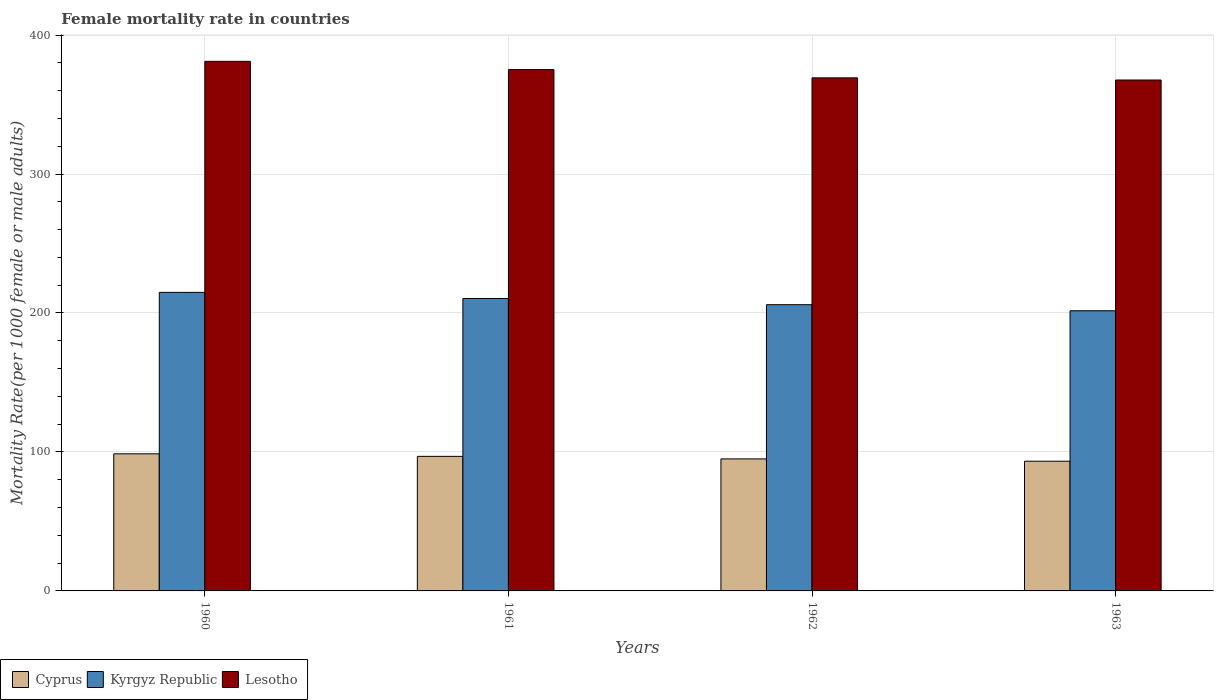How many different coloured bars are there?
Give a very brief answer. 3. Are the number of bars on each tick of the X-axis equal?
Ensure brevity in your answer.  Yes. How many bars are there on the 1st tick from the right?
Offer a very short reply. 3. In how many cases, is the number of bars for a given year not equal to the number of legend labels?
Make the answer very short. 0. What is the female mortality rate in Cyprus in 1960?
Keep it short and to the point. 98.65. Across all years, what is the maximum female mortality rate in Lesotho?
Offer a terse response. 381.07. Across all years, what is the minimum female mortality rate in Kyrgyz Republic?
Offer a terse response. 201.59. What is the total female mortality rate in Lesotho in the graph?
Ensure brevity in your answer.  1493.04. What is the difference between the female mortality rate in Cyprus in 1960 and that in 1962?
Provide a short and direct response. 3.65. What is the difference between the female mortality rate in Cyprus in 1962 and the female mortality rate in Lesotho in 1961?
Your response must be concise. -280.13. What is the average female mortality rate in Kyrgyz Republic per year?
Keep it short and to the point. 208.2. In the year 1961, what is the difference between the female mortality rate in Cyprus and female mortality rate in Kyrgyz Republic?
Your answer should be compact. -113.57. In how many years, is the female mortality rate in Cyprus greater than 80?
Your response must be concise. 4. What is the ratio of the female mortality rate in Cyprus in 1960 to that in 1962?
Ensure brevity in your answer.  1.04. Is the difference between the female mortality rate in Cyprus in 1961 and 1963 greater than the difference between the female mortality rate in Kyrgyz Republic in 1961 and 1963?
Make the answer very short. No. What is the difference between the highest and the second highest female mortality rate in Kyrgyz Republic?
Ensure brevity in your answer.  4.44. What is the difference between the highest and the lowest female mortality rate in Cyprus?
Provide a succinct answer. 5.32. In how many years, is the female mortality rate in Kyrgyz Republic greater than the average female mortality rate in Kyrgyz Republic taken over all years?
Keep it short and to the point. 2. What does the 2nd bar from the left in 1962 represents?
Provide a short and direct response. Kyrgyz Republic. What does the 3rd bar from the right in 1963 represents?
Offer a terse response. Cyprus. Is it the case that in every year, the sum of the female mortality rate in Cyprus and female mortality rate in Kyrgyz Republic is greater than the female mortality rate in Lesotho?
Offer a terse response. No. How many bars are there?
Offer a terse response. 12. How many years are there in the graph?
Provide a short and direct response. 4. What is the difference between two consecutive major ticks on the Y-axis?
Your answer should be very brief. 100. Does the graph contain any zero values?
Provide a short and direct response. No. How many legend labels are there?
Your answer should be compact. 3. What is the title of the graph?
Offer a very short reply. Female mortality rate in countries. Does "Turkey" appear as one of the legend labels in the graph?
Provide a short and direct response. No. What is the label or title of the X-axis?
Offer a very short reply. Years. What is the label or title of the Y-axis?
Your answer should be very brief. Mortality Rate(per 1000 female or male adults). What is the Mortality Rate(per 1000 female or male adults) in Cyprus in 1960?
Your answer should be compact. 98.65. What is the Mortality Rate(per 1000 female or male adults) of Kyrgyz Republic in 1960?
Make the answer very short. 214.84. What is the Mortality Rate(per 1000 female or male adults) of Lesotho in 1960?
Your answer should be very brief. 381.07. What is the Mortality Rate(per 1000 female or male adults) in Cyprus in 1961?
Your answer should be compact. 96.83. What is the Mortality Rate(per 1000 female or male adults) in Kyrgyz Republic in 1961?
Your answer should be very brief. 210.4. What is the Mortality Rate(per 1000 female or male adults) in Lesotho in 1961?
Provide a succinct answer. 375.13. What is the Mortality Rate(per 1000 female or male adults) in Cyprus in 1962?
Your answer should be compact. 95. What is the Mortality Rate(per 1000 female or male adults) in Kyrgyz Republic in 1962?
Provide a succinct answer. 205.97. What is the Mortality Rate(per 1000 female or male adults) in Lesotho in 1962?
Offer a very short reply. 369.19. What is the Mortality Rate(per 1000 female or male adults) in Cyprus in 1963?
Offer a very short reply. 93.34. What is the Mortality Rate(per 1000 female or male adults) of Kyrgyz Republic in 1963?
Make the answer very short. 201.59. What is the Mortality Rate(per 1000 female or male adults) in Lesotho in 1963?
Provide a short and direct response. 367.65. Across all years, what is the maximum Mortality Rate(per 1000 female or male adults) of Cyprus?
Your answer should be very brief. 98.65. Across all years, what is the maximum Mortality Rate(per 1000 female or male adults) of Kyrgyz Republic?
Your answer should be very brief. 214.84. Across all years, what is the maximum Mortality Rate(per 1000 female or male adults) of Lesotho?
Make the answer very short. 381.07. Across all years, what is the minimum Mortality Rate(per 1000 female or male adults) in Cyprus?
Make the answer very short. 93.34. Across all years, what is the minimum Mortality Rate(per 1000 female or male adults) of Kyrgyz Republic?
Your answer should be very brief. 201.59. Across all years, what is the minimum Mortality Rate(per 1000 female or male adults) in Lesotho?
Provide a succinct answer. 367.65. What is the total Mortality Rate(per 1000 female or male adults) in Cyprus in the graph?
Ensure brevity in your answer.  383.82. What is the total Mortality Rate(per 1000 female or male adults) in Kyrgyz Republic in the graph?
Make the answer very short. 832.8. What is the total Mortality Rate(per 1000 female or male adults) of Lesotho in the graph?
Make the answer very short. 1493.04. What is the difference between the Mortality Rate(per 1000 female or male adults) of Cyprus in 1960 and that in 1961?
Your response must be concise. 1.82. What is the difference between the Mortality Rate(per 1000 female or male adults) in Kyrgyz Republic in 1960 and that in 1961?
Your answer should be compact. 4.43. What is the difference between the Mortality Rate(per 1000 female or male adults) in Lesotho in 1960 and that in 1961?
Make the answer very short. 5.94. What is the difference between the Mortality Rate(per 1000 female or male adults) of Cyprus in 1960 and that in 1962?
Ensure brevity in your answer.  3.65. What is the difference between the Mortality Rate(per 1000 female or male adults) in Kyrgyz Republic in 1960 and that in 1962?
Make the answer very short. 8.87. What is the difference between the Mortality Rate(per 1000 female or male adults) of Lesotho in 1960 and that in 1962?
Ensure brevity in your answer.  11.87. What is the difference between the Mortality Rate(per 1000 female or male adults) in Cyprus in 1960 and that in 1963?
Provide a short and direct response. 5.32. What is the difference between the Mortality Rate(per 1000 female or male adults) of Kyrgyz Republic in 1960 and that in 1963?
Keep it short and to the point. 13.24. What is the difference between the Mortality Rate(per 1000 female or male adults) in Lesotho in 1960 and that in 1963?
Make the answer very short. 13.42. What is the difference between the Mortality Rate(per 1000 female or male adults) of Cyprus in 1961 and that in 1962?
Your answer should be compact. 1.82. What is the difference between the Mortality Rate(per 1000 female or male adults) in Kyrgyz Republic in 1961 and that in 1962?
Make the answer very short. 4.43. What is the difference between the Mortality Rate(per 1000 female or male adults) of Lesotho in 1961 and that in 1962?
Your answer should be compact. 5.94. What is the difference between the Mortality Rate(per 1000 female or male adults) in Cyprus in 1961 and that in 1963?
Provide a short and direct response. 3.49. What is the difference between the Mortality Rate(per 1000 female or male adults) of Kyrgyz Republic in 1961 and that in 1963?
Offer a terse response. 8.81. What is the difference between the Mortality Rate(per 1000 female or male adults) of Lesotho in 1961 and that in 1963?
Keep it short and to the point. 7.48. What is the difference between the Mortality Rate(per 1000 female or male adults) of Cyprus in 1962 and that in 1963?
Your response must be concise. 1.67. What is the difference between the Mortality Rate(per 1000 female or male adults) of Kyrgyz Republic in 1962 and that in 1963?
Offer a very short reply. 4.37. What is the difference between the Mortality Rate(per 1000 female or male adults) of Lesotho in 1962 and that in 1963?
Offer a terse response. 1.55. What is the difference between the Mortality Rate(per 1000 female or male adults) of Cyprus in 1960 and the Mortality Rate(per 1000 female or male adults) of Kyrgyz Republic in 1961?
Keep it short and to the point. -111.75. What is the difference between the Mortality Rate(per 1000 female or male adults) of Cyprus in 1960 and the Mortality Rate(per 1000 female or male adults) of Lesotho in 1961?
Give a very brief answer. -276.48. What is the difference between the Mortality Rate(per 1000 female or male adults) in Kyrgyz Republic in 1960 and the Mortality Rate(per 1000 female or male adults) in Lesotho in 1961?
Provide a succinct answer. -160.29. What is the difference between the Mortality Rate(per 1000 female or male adults) in Cyprus in 1960 and the Mortality Rate(per 1000 female or male adults) in Kyrgyz Republic in 1962?
Keep it short and to the point. -107.31. What is the difference between the Mortality Rate(per 1000 female or male adults) of Cyprus in 1960 and the Mortality Rate(per 1000 female or male adults) of Lesotho in 1962?
Ensure brevity in your answer.  -270.54. What is the difference between the Mortality Rate(per 1000 female or male adults) of Kyrgyz Republic in 1960 and the Mortality Rate(per 1000 female or male adults) of Lesotho in 1962?
Your response must be concise. -154.36. What is the difference between the Mortality Rate(per 1000 female or male adults) of Cyprus in 1960 and the Mortality Rate(per 1000 female or male adults) of Kyrgyz Republic in 1963?
Your answer should be compact. -102.94. What is the difference between the Mortality Rate(per 1000 female or male adults) in Cyprus in 1960 and the Mortality Rate(per 1000 female or male adults) in Lesotho in 1963?
Provide a short and direct response. -269. What is the difference between the Mortality Rate(per 1000 female or male adults) of Kyrgyz Republic in 1960 and the Mortality Rate(per 1000 female or male adults) of Lesotho in 1963?
Your answer should be very brief. -152.81. What is the difference between the Mortality Rate(per 1000 female or male adults) in Cyprus in 1961 and the Mortality Rate(per 1000 female or male adults) in Kyrgyz Republic in 1962?
Your answer should be compact. -109.14. What is the difference between the Mortality Rate(per 1000 female or male adults) in Cyprus in 1961 and the Mortality Rate(per 1000 female or male adults) in Lesotho in 1962?
Provide a succinct answer. -272.37. What is the difference between the Mortality Rate(per 1000 female or male adults) in Kyrgyz Republic in 1961 and the Mortality Rate(per 1000 female or male adults) in Lesotho in 1962?
Ensure brevity in your answer.  -158.79. What is the difference between the Mortality Rate(per 1000 female or male adults) in Cyprus in 1961 and the Mortality Rate(per 1000 female or male adults) in Kyrgyz Republic in 1963?
Make the answer very short. -104.77. What is the difference between the Mortality Rate(per 1000 female or male adults) of Cyprus in 1961 and the Mortality Rate(per 1000 female or male adults) of Lesotho in 1963?
Provide a short and direct response. -270.82. What is the difference between the Mortality Rate(per 1000 female or male adults) in Kyrgyz Republic in 1961 and the Mortality Rate(per 1000 female or male adults) in Lesotho in 1963?
Your answer should be compact. -157.25. What is the difference between the Mortality Rate(per 1000 female or male adults) of Cyprus in 1962 and the Mortality Rate(per 1000 female or male adults) of Kyrgyz Republic in 1963?
Provide a short and direct response. -106.59. What is the difference between the Mortality Rate(per 1000 female or male adults) in Cyprus in 1962 and the Mortality Rate(per 1000 female or male adults) in Lesotho in 1963?
Your answer should be compact. -272.64. What is the difference between the Mortality Rate(per 1000 female or male adults) in Kyrgyz Republic in 1962 and the Mortality Rate(per 1000 female or male adults) in Lesotho in 1963?
Keep it short and to the point. -161.68. What is the average Mortality Rate(per 1000 female or male adults) of Cyprus per year?
Offer a terse response. 95.96. What is the average Mortality Rate(per 1000 female or male adults) in Kyrgyz Republic per year?
Offer a terse response. 208.2. What is the average Mortality Rate(per 1000 female or male adults) of Lesotho per year?
Your answer should be very brief. 373.26. In the year 1960, what is the difference between the Mortality Rate(per 1000 female or male adults) in Cyprus and Mortality Rate(per 1000 female or male adults) in Kyrgyz Republic?
Give a very brief answer. -116.18. In the year 1960, what is the difference between the Mortality Rate(per 1000 female or male adults) in Cyprus and Mortality Rate(per 1000 female or male adults) in Lesotho?
Provide a succinct answer. -282.42. In the year 1960, what is the difference between the Mortality Rate(per 1000 female or male adults) in Kyrgyz Republic and Mortality Rate(per 1000 female or male adults) in Lesotho?
Offer a terse response. -166.23. In the year 1961, what is the difference between the Mortality Rate(per 1000 female or male adults) in Cyprus and Mortality Rate(per 1000 female or male adults) in Kyrgyz Republic?
Provide a succinct answer. -113.57. In the year 1961, what is the difference between the Mortality Rate(per 1000 female or male adults) in Cyprus and Mortality Rate(per 1000 female or male adults) in Lesotho?
Offer a terse response. -278.3. In the year 1961, what is the difference between the Mortality Rate(per 1000 female or male adults) in Kyrgyz Republic and Mortality Rate(per 1000 female or male adults) in Lesotho?
Keep it short and to the point. -164.73. In the year 1962, what is the difference between the Mortality Rate(per 1000 female or male adults) in Cyprus and Mortality Rate(per 1000 female or male adults) in Kyrgyz Republic?
Your response must be concise. -110.96. In the year 1962, what is the difference between the Mortality Rate(per 1000 female or male adults) in Cyprus and Mortality Rate(per 1000 female or male adults) in Lesotho?
Provide a succinct answer. -274.19. In the year 1962, what is the difference between the Mortality Rate(per 1000 female or male adults) in Kyrgyz Republic and Mortality Rate(per 1000 female or male adults) in Lesotho?
Keep it short and to the point. -163.23. In the year 1963, what is the difference between the Mortality Rate(per 1000 female or male adults) of Cyprus and Mortality Rate(per 1000 female or male adults) of Kyrgyz Republic?
Provide a succinct answer. -108.26. In the year 1963, what is the difference between the Mortality Rate(per 1000 female or male adults) of Cyprus and Mortality Rate(per 1000 female or male adults) of Lesotho?
Make the answer very short. -274.31. In the year 1963, what is the difference between the Mortality Rate(per 1000 female or male adults) in Kyrgyz Republic and Mortality Rate(per 1000 female or male adults) in Lesotho?
Ensure brevity in your answer.  -166.05. What is the ratio of the Mortality Rate(per 1000 female or male adults) of Cyprus in 1960 to that in 1961?
Offer a terse response. 1.02. What is the ratio of the Mortality Rate(per 1000 female or male adults) in Kyrgyz Republic in 1960 to that in 1961?
Your response must be concise. 1.02. What is the ratio of the Mortality Rate(per 1000 female or male adults) in Lesotho in 1960 to that in 1961?
Ensure brevity in your answer.  1.02. What is the ratio of the Mortality Rate(per 1000 female or male adults) of Cyprus in 1960 to that in 1962?
Provide a short and direct response. 1.04. What is the ratio of the Mortality Rate(per 1000 female or male adults) in Kyrgyz Republic in 1960 to that in 1962?
Offer a very short reply. 1.04. What is the ratio of the Mortality Rate(per 1000 female or male adults) in Lesotho in 1960 to that in 1962?
Your answer should be very brief. 1.03. What is the ratio of the Mortality Rate(per 1000 female or male adults) in Cyprus in 1960 to that in 1963?
Keep it short and to the point. 1.06. What is the ratio of the Mortality Rate(per 1000 female or male adults) of Kyrgyz Republic in 1960 to that in 1963?
Offer a very short reply. 1.07. What is the ratio of the Mortality Rate(per 1000 female or male adults) of Lesotho in 1960 to that in 1963?
Your answer should be compact. 1.04. What is the ratio of the Mortality Rate(per 1000 female or male adults) in Cyprus in 1961 to that in 1962?
Your answer should be compact. 1.02. What is the ratio of the Mortality Rate(per 1000 female or male adults) of Kyrgyz Republic in 1961 to that in 1962?
Your answer should be very brief. 1.02. What is the ratio of the Mortality Rate(per 1000 female or male adults) of Lesotho in 1961 to that in 1962?
Keep it short and to the point. 1.02. What is the ratio of the Mortality Rate(per 1000 female or male adults) in Cyprus in 1961 to that in 1963?
Give a very brief answer. 1.04. What is the ratio of the Mortality Rate(per 1000 female or male adults) in Kyrgyz Republic in 1961 to that in 1963?
Provide a short and direct response. 1.04. What is the ratio of the Mortality Rate(per 1000 female or male adults) of Lesotho in 1961 to that in 1963?
Keep it short and to the point. 1.02. What is the ratio of the Mortality Rate(per 1000 female or male adults) of Cyprus in 1962 to that in 1963?
Your answer should be compact. 1.02. What is the ratio of the Mortality Rate(per 1000 female or male adults) in Kyrgyz Republic in 1962 to that in 1963?
Make the answer very short. 1.02. What is the ratio of the Mortality Rate(per 1000 female or male adults) of Lesotho in 1962 to that in 1963?
Offer a terse response. 1. What is the difference between the highest and the second highest Mortality Rate(per 1000 female or male adults) of Cyprus?
Give a very brief answer. 1.82. What is the difference between the highest and the second highest Mortality Rate(per 1000 female or male adults) in Kyrgyz Republic?
Offer a very short reply. 4.43. What is the difference between the highest and the second highest Mortality Rate(per 1000 female or male adults) in Lesotho?
Your answer should be compact. 5.94. What is the difference between the highest and the lowest Mortality Rate(per 1000 female or male adults) of Cyprus?
Your answer should be very brief. 5.32. What is the difference between the highest and the lowest Mortality Rate(per 1000 female or male adults) in Kyrgyz Republic?
Ensure brevity in your answer.  13.24. What is the difference between the highest and the lowest Mortality Rate(per 1000 female or male adults) of Lesotho?
Your response must be concise. 13.42. 